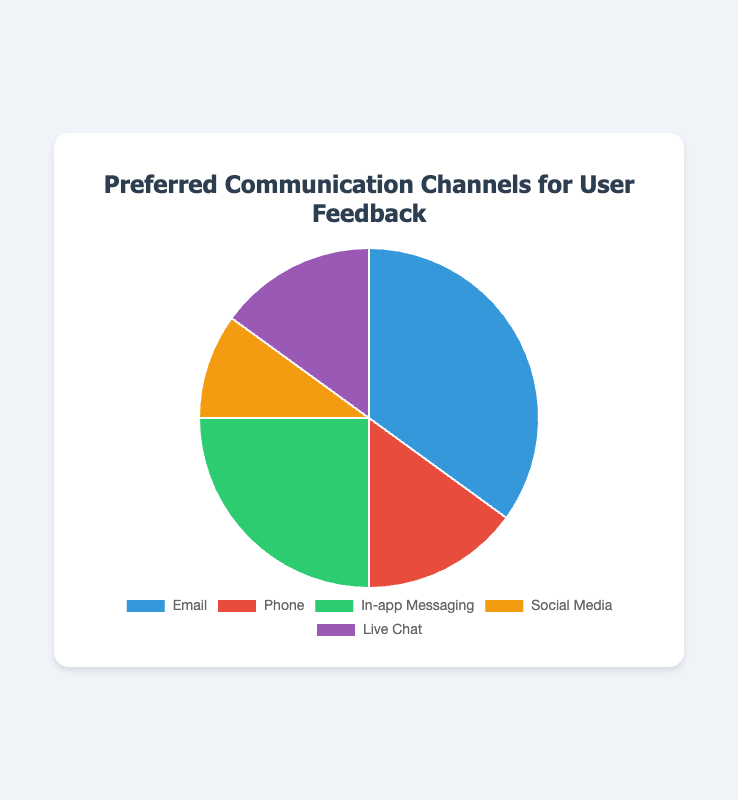what proportion of users prefer 'Email' to 'Live Chat'? 'Email' has 35% and 'Live Chat' has 15%. The proportion of users who prefer 'Email' to 'Live Chat' is 35% / 15%.
Answer: 35% / 15% which communication channels have the same percentage of preference? 'Phone' and 'Live Chat' both have a preference rate of 15%.
Answer: Phone and Live Chat if we combine 'In-app Messaging' and 'Social Media,' what will be their total preference? 'In-app Messaging' is 25% and 'Social Media' is 10%. The combined preference is 25% + 10%.
Answer: 35% what is the difference in preference between the most and least preferred communication channels? The most preferred channel is 'Email' at 35%, and the least preferred is 'Social Media' at 10%. The difference is 35% - 10%.
Answer: 25% which channel represents the second highest preference for user feedback? 'Email' is the highest at 35%, and the second highest is 'In-app Messaging' at 25%.
Answer: In-app Messaging if 'Phone' and 'Live Chat' are merged into one group, how does their combined preference compare to 'Email'? The combined preference for 'Phone' and 'Live Chat' is 15% + 15% = 30%. 'Email' is at 35%. 35% > 30%.
Answer: less preferred what color represents 'Social Media' in the pie chart? The pie chart uses yellow to represent 'Social Media'.
Answer: yellow how many more times is 'Email' preferred compared to 'Phone'? 'Email' is 35% and 'Phone' is 15%. The proportion is 35 / 15.
Answer: 2.33 times which communication channels have less than 20% preference? 'Phone,' 'Social Media,' and 'Live Chat' all have less than 20% preference.
Answer: Phone, Social Media, Live Chat what's the combined percentage for all channels except 'Email'? Adding up 'Phone' (15%), 'In-app Messaging' (25%), 'Social Media' (10%), and 'Live Chat' (15%) gives 65%.
Answer: 65% 